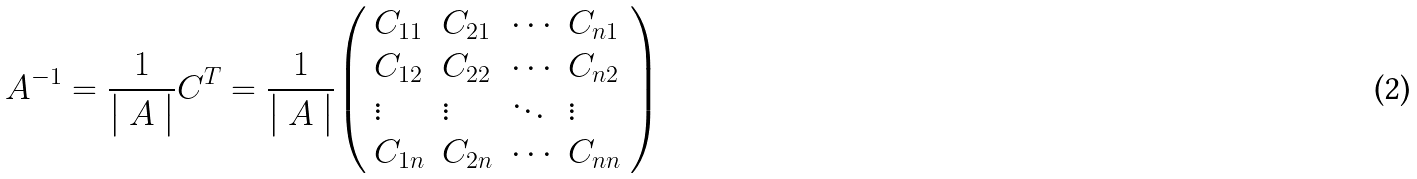Convert formula to latex. <formula><loc_0><loc_0><loc_500><loc_500>A ^ { - 1 } = { \frac { 1 } { \left | \begin{array} { l } { A } \end{array} \right | } } C ^ { T } = { \frac { 1 } { \left | \begin{array} { l } { A } \end{array} \right | } } { \left ( \begin{array} { l l l l } { C _ { 1 1 } } & { C _ { 2 1 } } & { \cdots } & { C _ { n 1 } } \\ { C _ { 1 2 } } & { C _ { 2 2 } } & { \cdots } & { C _ { n 2 } } \\ { \vdots } & { \vdots } & { \ddots } & { \vdots } \\ { C _ { 1 n } } & { C _ { 2 n } } & { \cdots } & { C _ { n n } } \end{array} \right ) }</formula> 